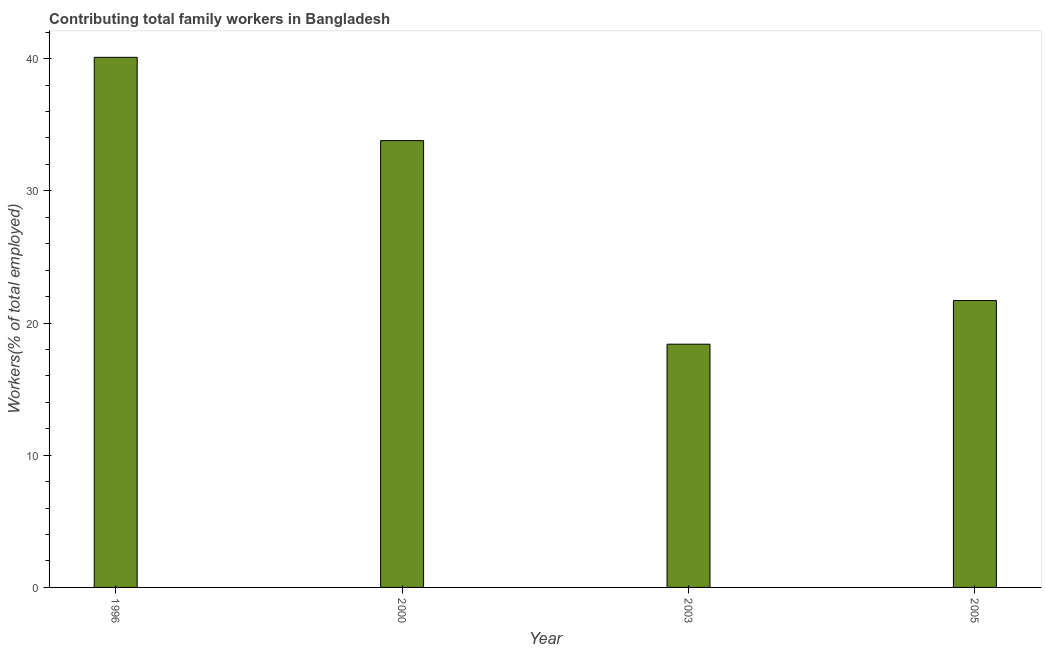Does the graph contain any zero values?
Your answer should be compact. No. Does the graph contain grids?
Keep it short and to the point. No. What is the title of the graph?
Make the answer very short. Contributing total family workers in Bangladesh. What is the label or title of the X-axis?
Keep it short and to the point. Year. What is the label or title of the Y-axis?
Provide a succinct answer. Workers(% of total employed). What is the contributing family workers in 2000?
Make the answer very short. 33.8. Across all years, what is the maximum contributing family workers?
Your answer should be very brief. 40.1. Across all years, what is the minimum contributing family workers?
Your answer should be compact. 18.4. What is the sum of the contributing family workers?
Your answer should be very brief. 114. What is the average contributing family workers per year?
Ensure brevity in your answer.  28.5. What is the median contributing family workers?
Your answer should be compact. 27.75. In how many years, is the contributing family workers greater than 2 %?
Make the answer very short. 4. Do a majority of the years between 2003 and 2005 (inclusive) have contributing family workers greater than 36 %?
Your response must be concise. No. What is the ratio of the contributing family workers in 2000 to that in 2003?
Ensure brevity in your answer.  1.84. What is the difference between the highest and the second highest contributing family workers?
Your answer should be very brief. 6.3. Is the sum of the contributing family workers in 2000 and 2003 greater than the maximum contributing family workers across all years?
Offer a very short reply. Yes. What is the difference between the highest and the lowest contributing family workers?
Provide a short and direct response. 21.7. In how many years, is the contributing family workers greater than the average contributing family workers taken over all years?
Give a very brief answer. 2. How many years are there in the graph?
Offer a terse response. 4. Are the values on the major ticks of Y-axis written in scientific E-notation?
Offer a very short reply. No. What is the Workers(% of total employed) of 1996?
Provide a succinct answer. 40.1. What is the Workers(% of total employed) in 2000?
Your answer should be compact. 33.8. What is the Workers(% of total employed) in 2003?
Keep it short and to the point. 18.4. What is the Workers(% of total employed) of 2005?
Give a very brief answer. 21.7. What is the difference between the Workers(% of total employed) in 1996 and 2000?
Ensure brevity in your answer.  6.3. What is the difference between the Workers(% of total employed) in 1996 and 2003?
Your response must be concise. 21.7. What is the difference between the Workers(% of total employed) in 1996 and 2005?
Give a very brief answer. 18.4. What is the difference between the Workers(% of total employed) in 2000 and 2005?
Provide a succinct answer. 12.1. What is the difference between the Workers(% of total employed) in 2003 and 2005?
Your answer should be compact. -3.3. What is the ratio of the Workers(% of total employed) in 1996 to that in 2000?
Make the answer very short. 1.19. What is the ratio of the Workers(% of total employed) in 1996 to that in 2003?
Your answer should be very brief. 2.18. What is the ratio of the Workers(% of total employed) in 1996 to that in 2005?
Ensure brevity in your answer.  1.85. What is the ratio of the Workers(% of total employed) in 2000 to that in 2003?
Offer a very short reply. 1.84. What is the ratio of the Workers(% of total employed) in 2000 to that in 2005?
Provide a succinct answer. 1.56. What is the ratio of the Workers(% of total employed) in 2003 to that in 2005?
Make the answer very short. 0.85. 